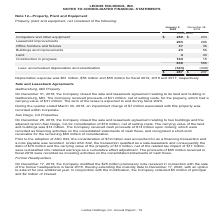From Leidos Holdings's financial document, What was the depreciation expense in 2019, 2018 and 2017 respectively? The document contains multiple relevant values: $61 million, $56 million, $55 million. From the document: "Depreciation expense was $61 million , $56 million and $55 million for fiscal 2019, 2018 and 2017, respectively. eciation expense was $61 million , $5..." Also, What was the Computers and other equipment in January 2020? According to the financial document, $259 (in millions). The relevant text states: "(in millions) Computers and other equipment $ 259 $ 233 Leasehold improvements 203 206 Office furniture and fixtures 37 36 Buildings and improvements..." Also, What was the Leasehold improvements in 2018? According to the financial document, 206 (in millions). The relevant text states: "equipment $ 259 $ 233 Leasehold improvements 203 206 Office furniture and fixtures 37 36 Buildings and improvements 23 56 Land 4 40 Construction in prog..." Additionally, In which period was Computers and other equipment less than 250 million? According to the financial document, 2018. The relevant text states: "January 3, 2020 December 28, 2018..." Also, can you calculate: What was the change in the Leasehold improvements from 2018 to 2020? Based on the calculation: 203 - 206, the result is -3 (in millions). This is based on the information: "equipment $ 259 $ 233 Leasehold improvements 203 206 Office furniture and fixtures 37 36 Buildings and improvements 23 56 Land 4 40 Construction in prog ther equipment $ 259 $ 233 Leasehold improvemen..." The key data points involved are: 203, 206. Also, can you calculate: What was the percentage change in the Office furniture and fixtures from 2018 to 2020? To answer this question, I need to perform calculations using the financial data. The calculation is: (37-36)/36, which equals 2.78 (percentage). This is based on the information: "mprovements 203 206 Office furniture and fixtures 37 36 Buildings and improvements 23 56 Land 4 40 Construction in progress 104 15 ovements 203 206 Office furniture and fixtures 37 36 Buildings and im..." The key data points involved are: 36, 37. 